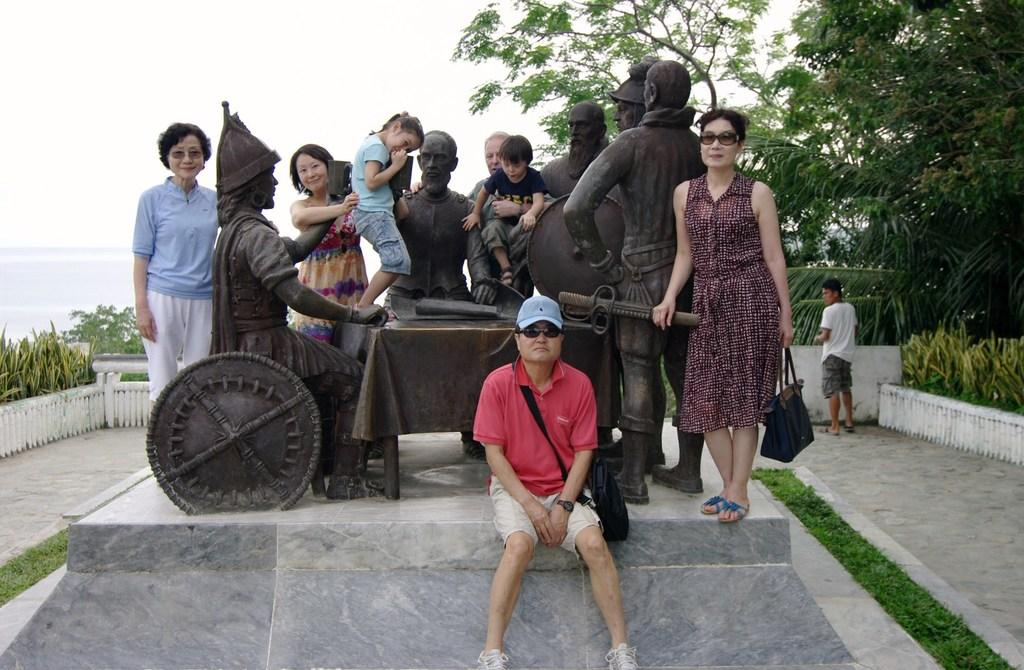What can be seen in the image? There are people standing in the image, along with statues and trees. What is visible in the background of the image? The sky is visible in the image. Where is the pocket located in the image? There is no pocket present in the image. What type of bath can be seen in the image? There is no bath present in the image. 